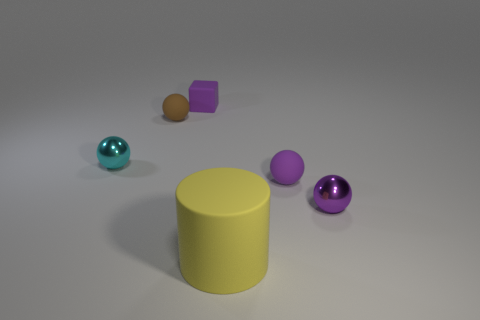Are there any other things that are the same size as the cylinder?
Offer a very short reply. No. What is the size of the rubber object in front of the rubber thing right of the yellow rubber cylinder?
Give a very brief answer. Large. How many things are either brown matte balls or small matte things right of the brown ball?
Make the answer very short. 3. There is a small shiny object on the left side of the purple shiny thing; is its shape the same as the brown object?
Your response must be concise. Yes. What number of tiny rubber spheres are to the right of the small metallic sphere that is behind the shiny thing that is to the right of the tiny cyan ball?
Ensure brevity in your answer.  2. Is there anything else that is the same shape as the brown rubber object?
Provide a succinct answer. Yes. What number of things are tiny purple balls or yellow rubber cylinders?
Your answer should be very brief. 3. Does the tiny purple metal object have the same shape as the small metallic thing on the left side of the cube?
Offer a terse response. Yes. There is a purple rubber object that is behind the small cyan ball; what shape is it?
Your response must be concise. Cube. Is the cyan metallic thing the same shape as the brown object?
Give a very brief answer. Yes. 